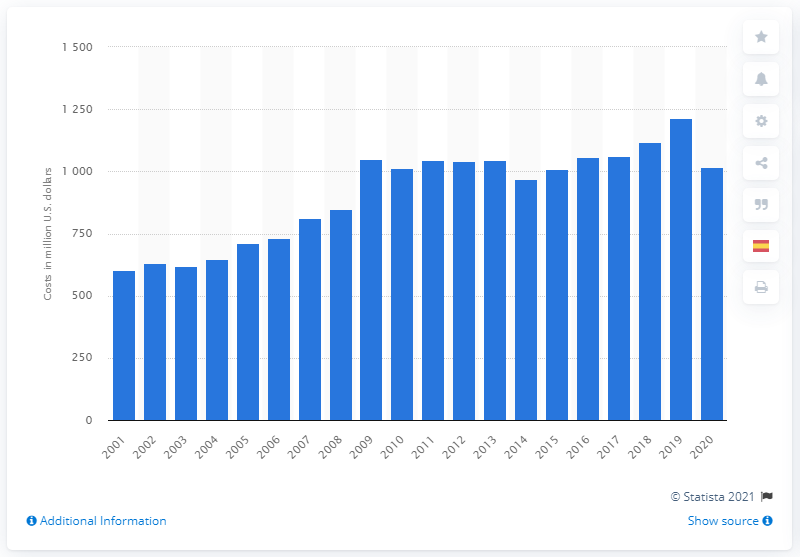Identify some key points in this picture. ExxonMobil spent $10.16 billion on research and development in 2020. 